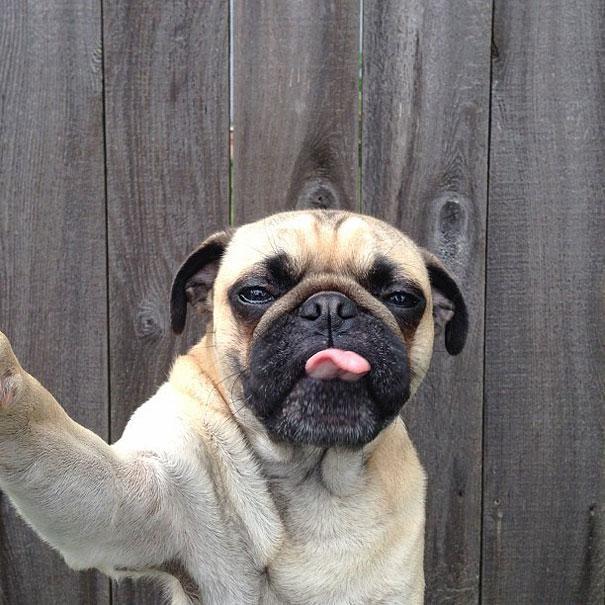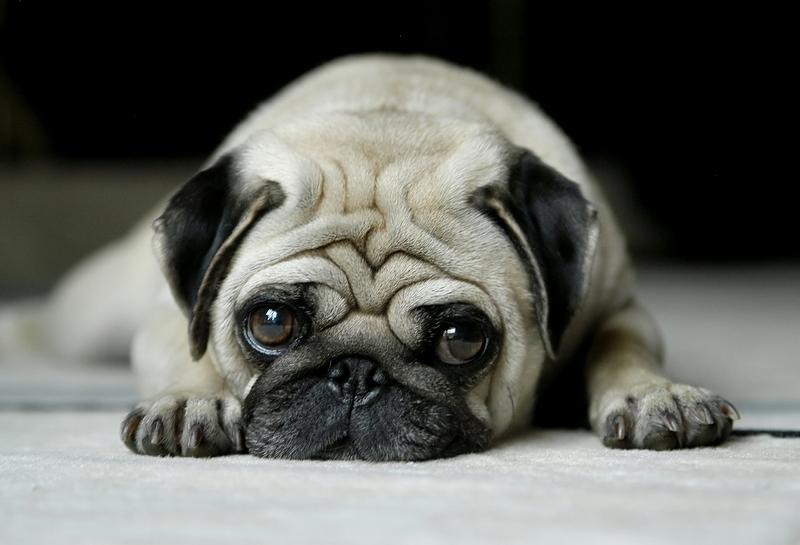The first image is the image on the left, the second image is the image on the right. For the images displayed, is the sentence "At least one pug is laying down." factually correct? Answer yes or no. Yes. The first image is the image on the left, the second image is the image on the right. Assess this claim about the two images: "There is one pug dog facing front, and at least one pug dog with its head turned slightly to the right.". Correct or not? Answer yes or no. No. 